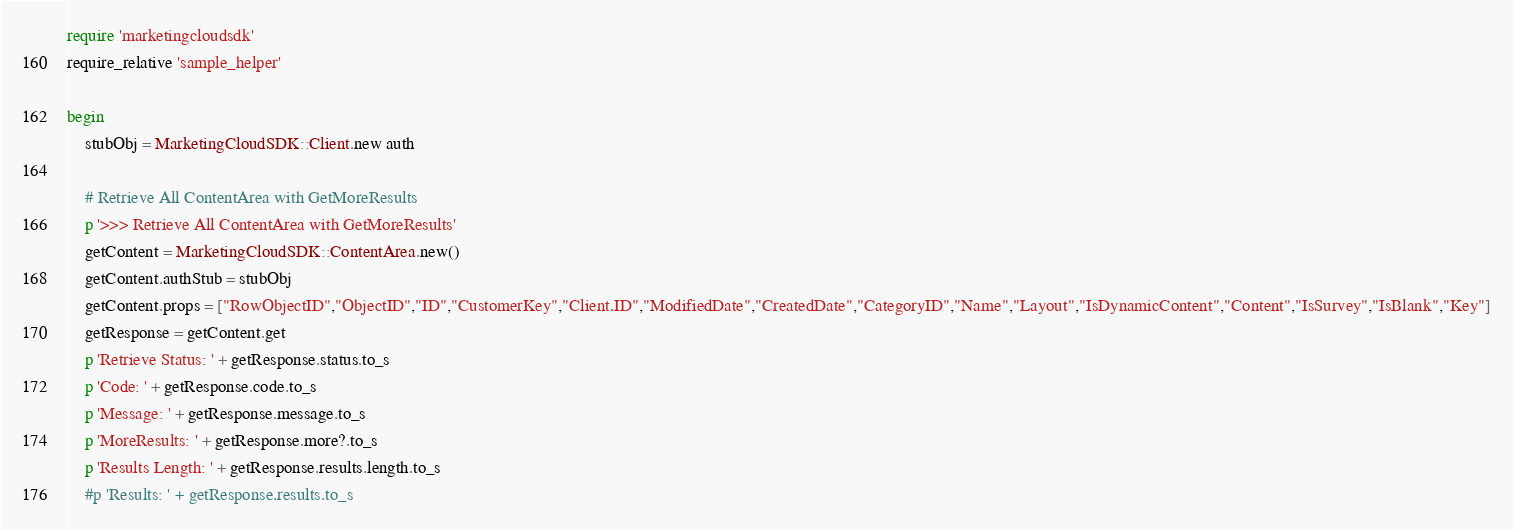Convert code to text. <code><loc_0><loc_0><loc_500><loc_500><_Ruby_>require 'marketingcloudsdk'
require_relative 'sample_helper'

begin
	stubObj = MarketingCloudSDK::Client.new auth

	# Retrieve All ContentArea with GetMoreResults
	p '>>> Retrieve All ContentArea with GetMoreResults'
	getContent = MarketingCloudSDK::ContentArea.new()
	getContent.authStub = stubObj
	getContent.props = ["RowObjectID","ObjectID","ID","CustomerKey","Client.ID","ModifiedDate","CreatedDate","CategoryID","Name","Layout","IsDynamicContent","Content","IsSurvey","IsBlank","Key"]
	getResponse = getContent.get
	p 'Retrieve Status: ' + getResponse.status.to_s
	p 'Code: ' + getResponse.code.to_s
	p 'Message: ' + getResponse.message.to_s
	p 'MoreResults: ' + getResponse.more?.to_s
	p 'Results Length: ' + getResponse.results.length.to_s
	#p 'Results: ' + getResponse.results.to_s</code> 